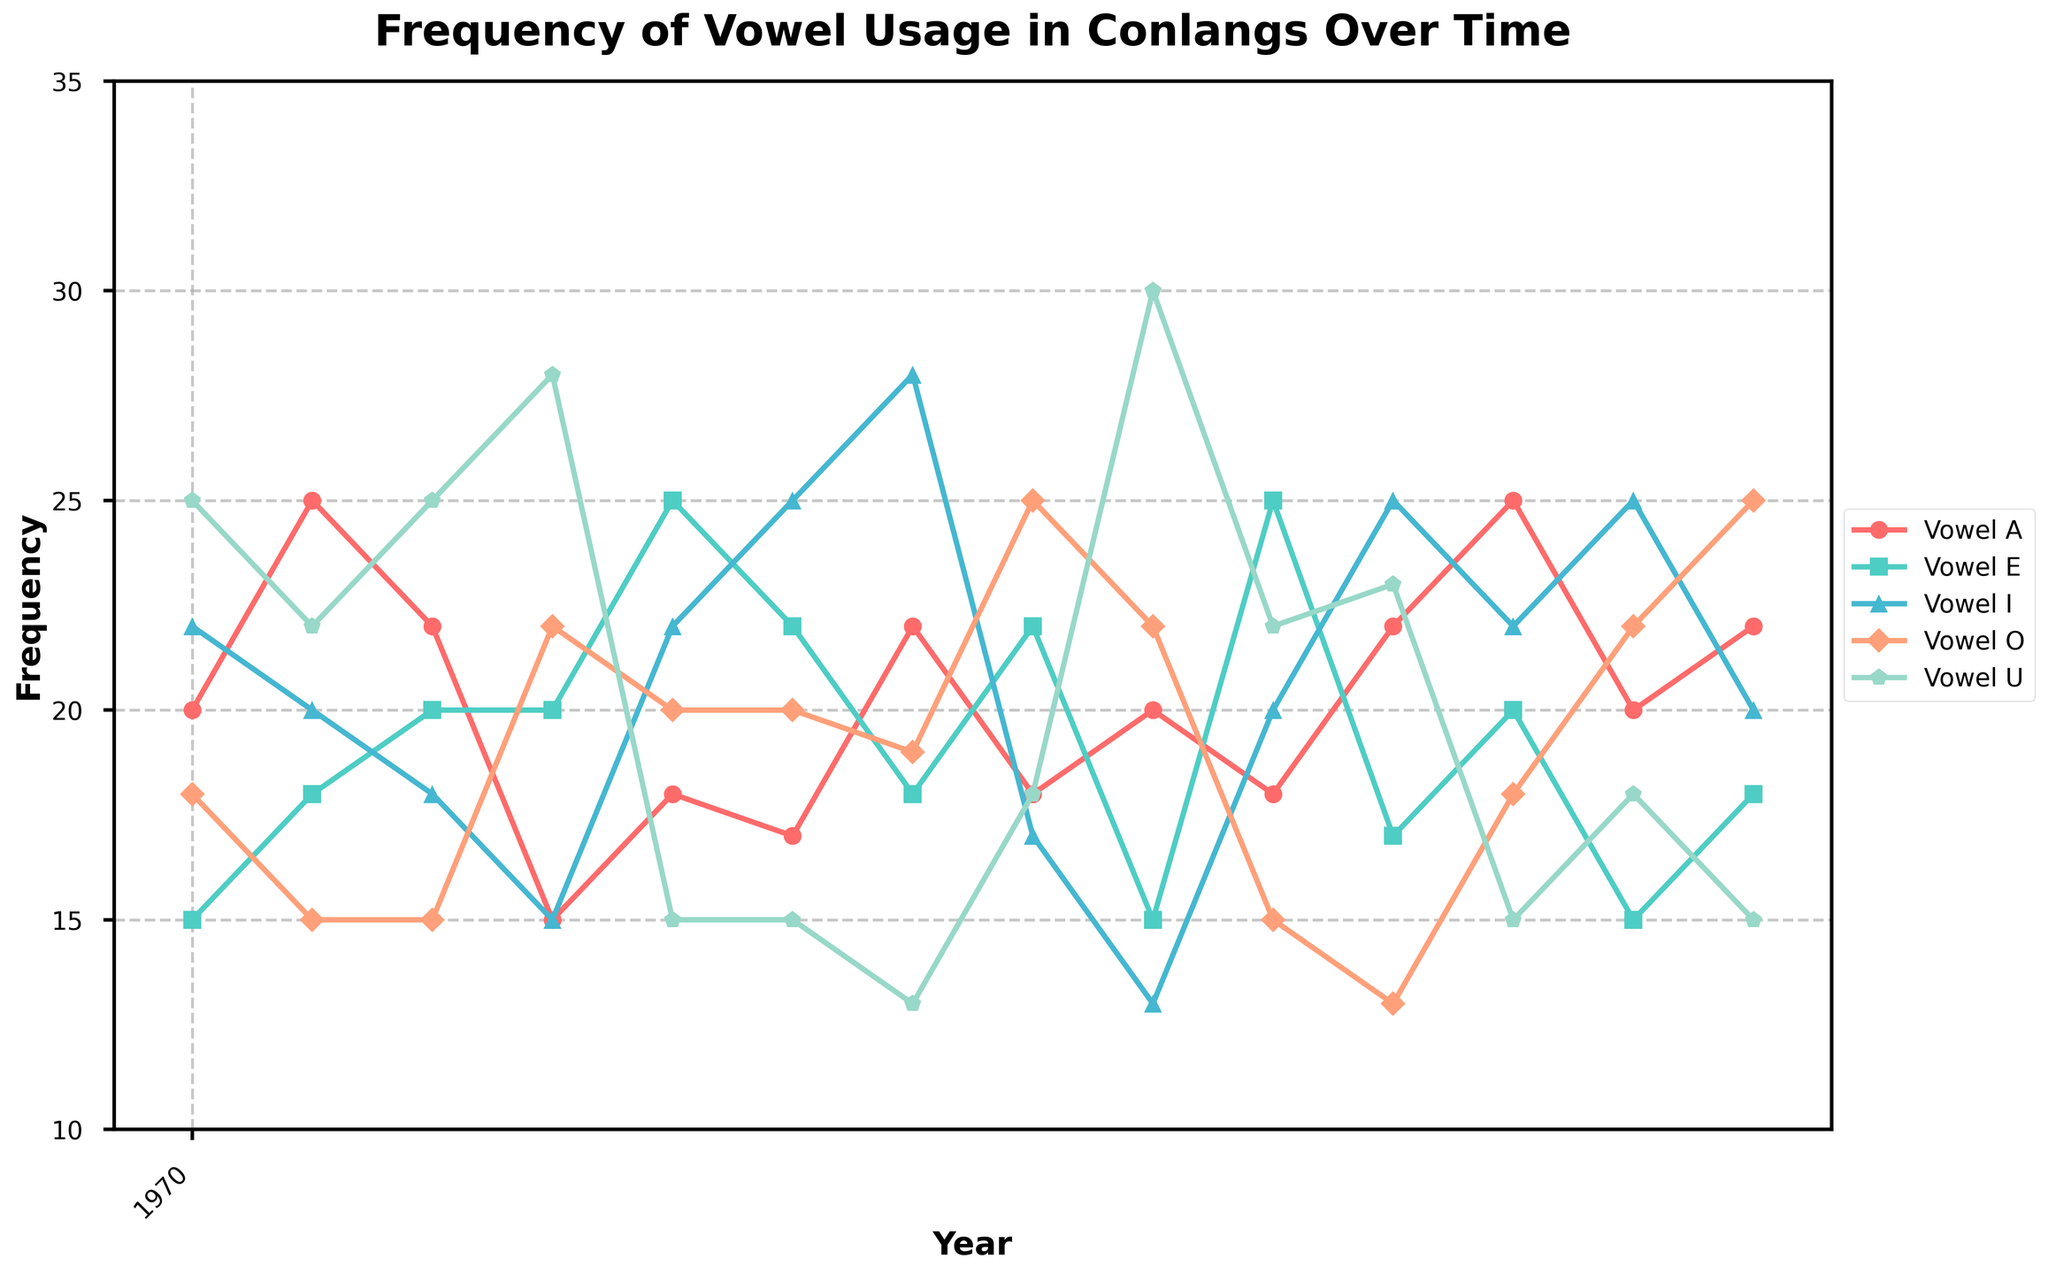What is the title of the plot? The title of the plot is written prominently at the top center of the figure. It summarizes the main subject of the plot, which is the frequency of vowel usage in conlangs over time.
Answer: Frequency of Vowel Usage in Conlangs Over Time Which year has the highest reported frequency of vowel "a"? To find the year with the highest frequency of vowel "a", look at the plot and identify the peak of the 'vowel_a' line. The frequency is highest in 2020.
Answer: 2020 What is the frequency of vowel "e" in 2018? Identify the point on the 'vowel_e' line that corresponds to the year 2018. The plot shows that the frequency is at 25 in 2018.
Answer: 25 How does the frequency of vowel "u" change from 2010 to 2022? Observe the 'vowel_u' line at 2010 and compare it to the value in 2022. The frequency starts at 25 in 2010 and drops to 15 in 2022.
Answer: Decreases by 10 Which vowel shows the most variability over the years? Look at the ups and downs of each vowel's line. Vowel "i" shows considerable fluctuations, with its values ranging widely across the years.
Answer: Vowel "i" In which year did vowel "o" have its lowest frequency? Look at the 'vowel_o' line and find the year where this value is the lowest. In 2019, vowel "o" has its lowest frequency, close to 13.
Answer: 2019 What is the average frequency of vowel "a" over the time period? Sum the frequencies of vowel "a" across all years and then divide by the number of data points. The frequencies are: 20+25+22+15+18+17+22+18+20+18+22+25+20+22, which sums to 284. Divided by the 14 data points, the average is approximately 20.29.
Answer: 20.29 How many unique creators are represented in the plot? Count the number of distinct names in the creator column of the plot's legend or dataset listing. There are seven unique creators listed.
Answer: 7 Which vowel shows the highest frequency in 2017? Compare the frequencies of all vowels in the year 2017. Vowel "u" has the highest frequency at 30 in 2017.
Answer: Vowel "u" Is there any year where all vowels have the same frequency? Examine each year's data points across all vowel lines to see if any intersect at the same frequency value. There is no year where all vowels share the same frequency.
Answer: No 